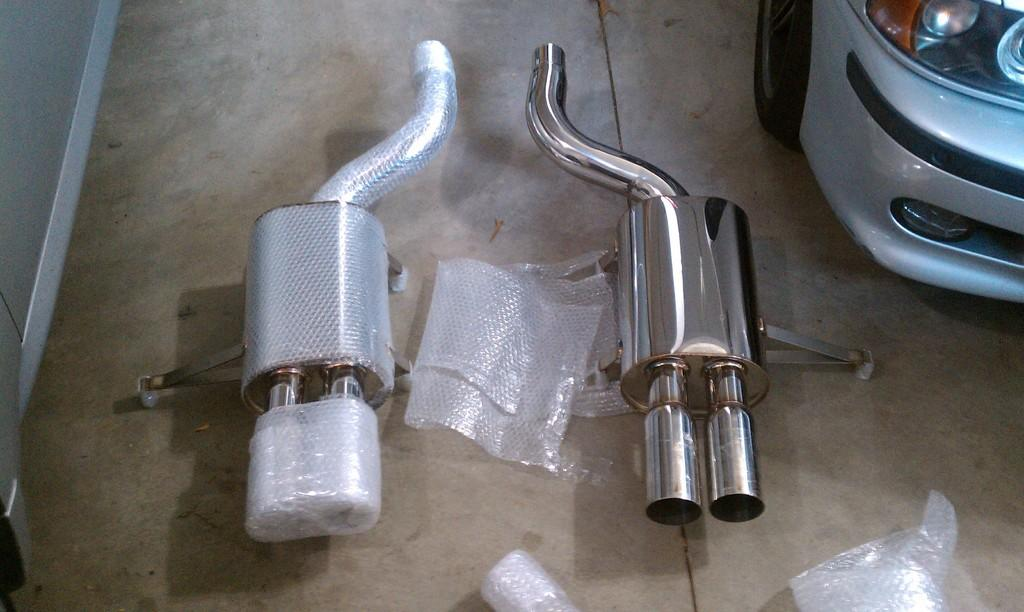What type of objects are present in the image? There are two stainless steel silencers in the image. Can you describe the vehicle in the image? There is a vehicle on the right side of the image. What color is the marble pig on the left side of the image? There is no marble pig present in the image; it only contains two stainless steel silencers and a vehicle. 